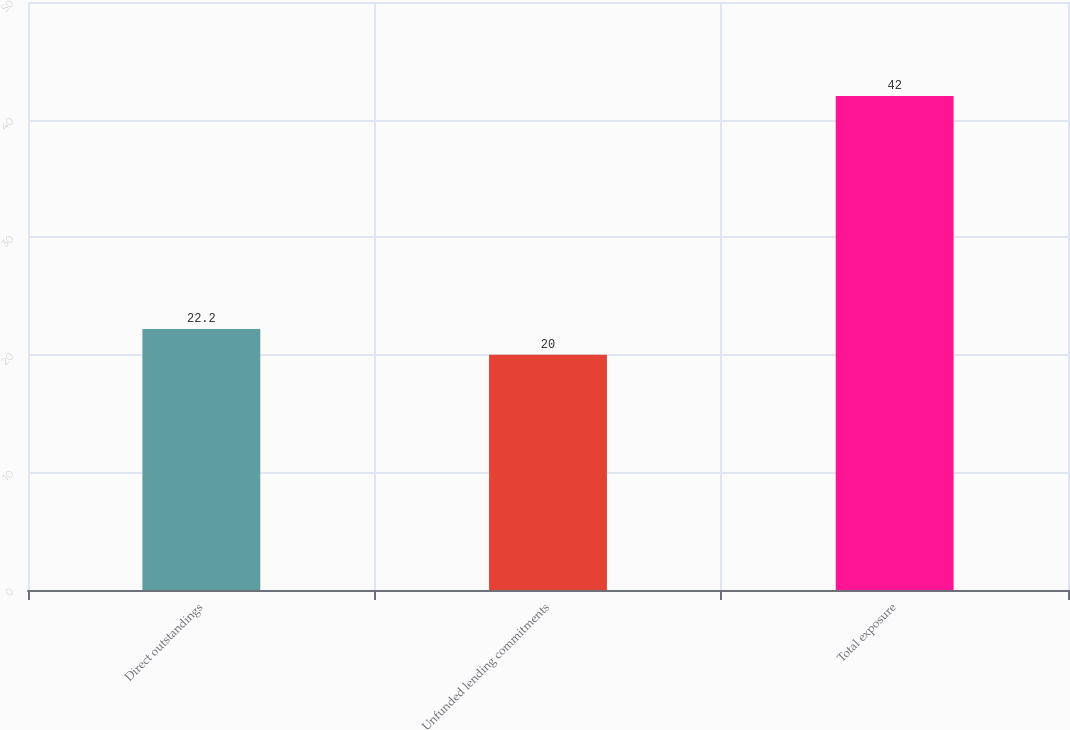<chart> <loc_0><loc_0><loc_500><loc_500><bar_chart><fcel>Direct outstandings<fcel>Unfunded lending commitments<fcel>Total exposure<nl><fcel>22.2<fcel>20<fcel>42<nl></chart> 